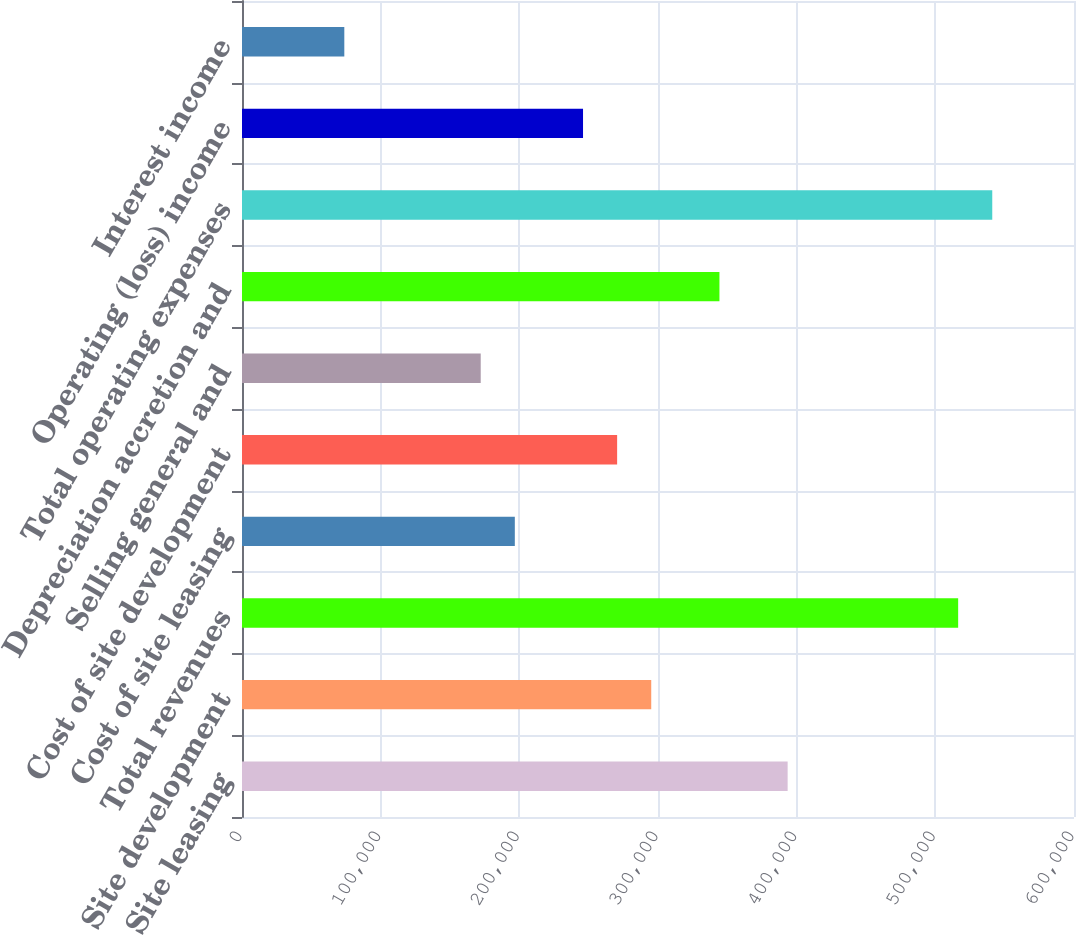Convert chart to OTSL. <chart><loc_0><loc_0><loc_500><loc_500><bar_chart><fcel>Site leasing<fcel>Site development<fcel>Total revenues<fcel>Cost of site leasing<fcel>Cost of site development<fcel>Selling general and<fcel>Depreciation accretion and<fcel>Total operating expenses<fcel>Operating (loss) income<fcel>Interest income<nl><fcel>393492<fcel>295120<fcel>516458<fcel>196748<fcel>270527<fcel>172155<fcel>344306<fcel>541051<fcel>245934<fcel>73782.6<nl></chart> 